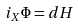<formula> <loc_0><loc_0><loc_500><loc_500>\, i _ { X } \Phi = d H</formula> 